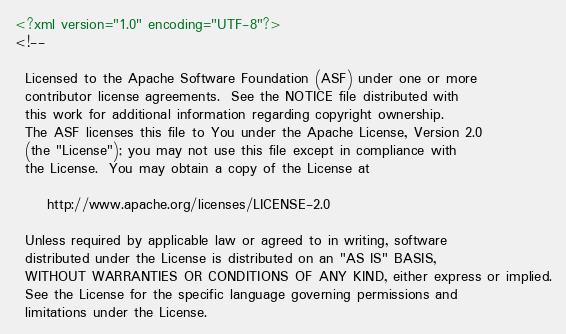Convert code to text. <code><loc_0><loc_0><loc_500><loc_500><_XML_><?xml version="1.0" encoding="UTF-8"?>
<!--

  Licensed to the Apache Software Foundation (ASF) under one or more
  contributor license agreements.  See the NOTICE file distributed with
  this work for additional information regarding copyright ownership.
  The ASF licenses this file to You under the Apache License, Version 2.0
  (the "License"); you may not use this file except in compliance with
  the License.  You may obtain a copy of the License at

      http://www.apache.org/licenses/LICENSE-2.0

  Unless required by applicable law or agreed to in writing, software
  distributed under the License is distributed on an "AS IS" BASIS,
  WITHOUT WARRANTIES OR CONDITIONS OF ANY KIND, either express or implied.
  See the License for the specific language governing permissions and
  limitations under the License.
</code> 